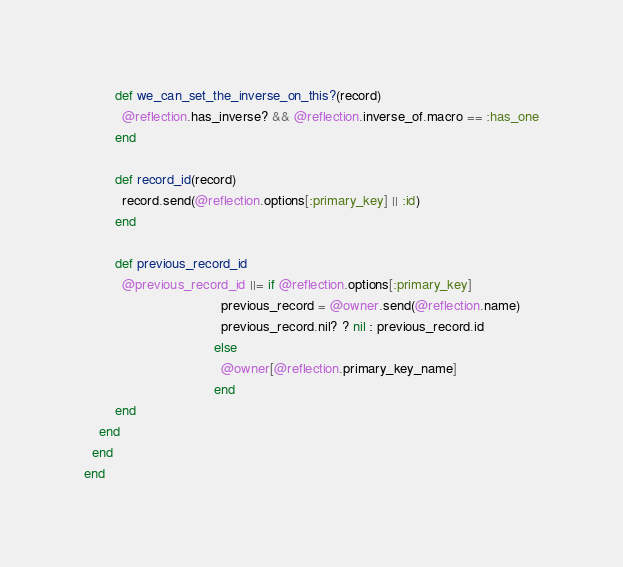<code> <loc_0><loc_0><loc_500><loc_500><_Ruby_>        def we_can_set_the_inverse_on_this?(record)
          @reflection.has_inverse? && @reflection.inverse_of.macro == :has_one
        end

        def record_id(record)
          record.send(@reflection.options[:primary_key] || :id)
        end

        def previous_record_id
          @previous_record_id ||= if @reflection.options[:primary_key]
                                    previous_record = @owner.send(@reflection.name)
                                    previous_record.nil? ? nil : previous_record.id
                                  else
                                    @owner[@reflection.primary_key_name]
                                  end
        end
    end
  end
end
</code> 